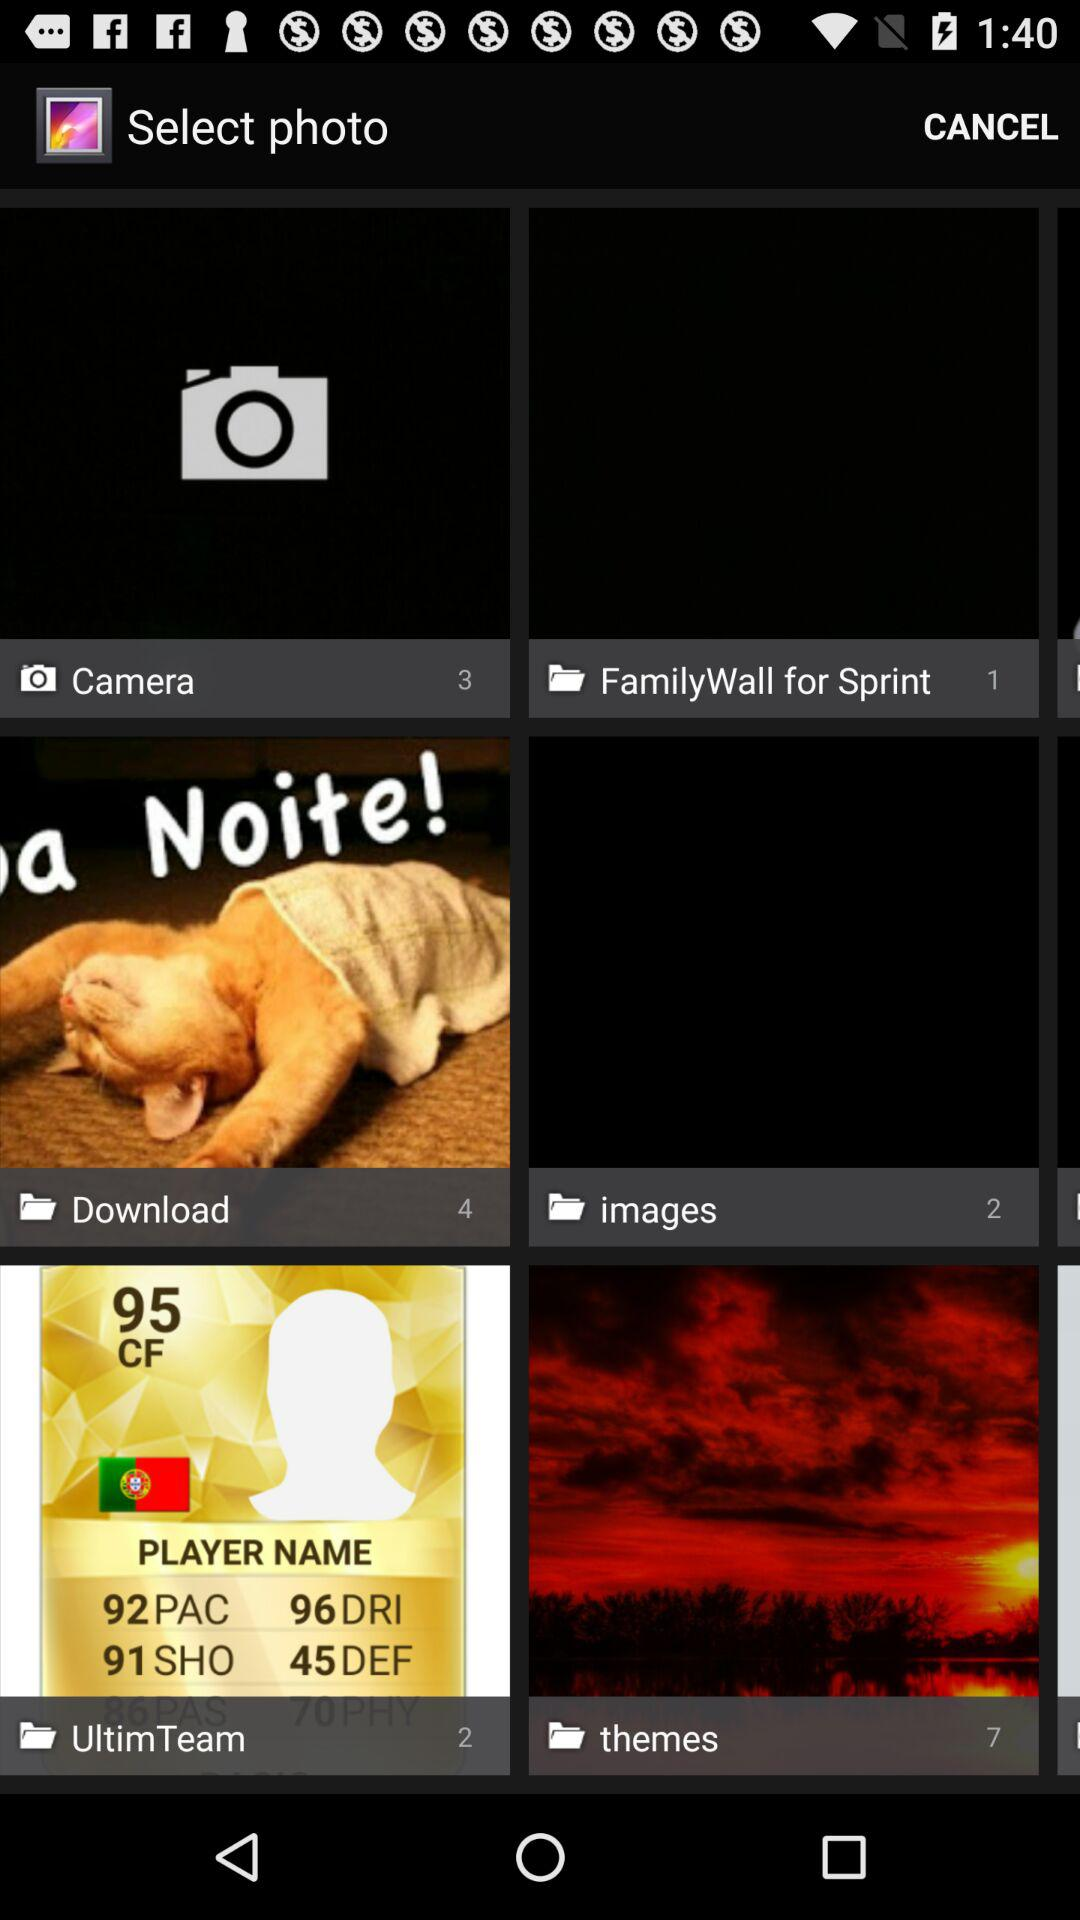How many images are in the "Download" folder? There are 4 images in the "Download" folder. 